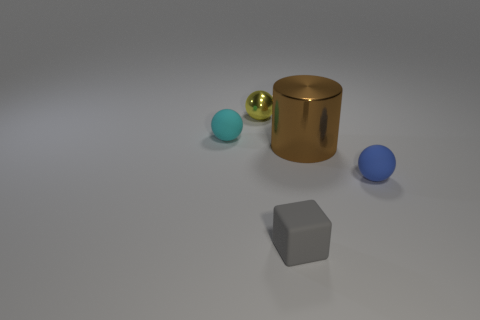Describe the lighting and mood of the scene. The lighting of the scene is soft and diffused, coming from the top and creating gentle shadows beneath the objects. This arrangement of lighting gives the scene a calm and minimalist atmosphere. There aren't any stark contrasts or dramatic highlights, which suggests a tranquil, almost studio-like environment. 